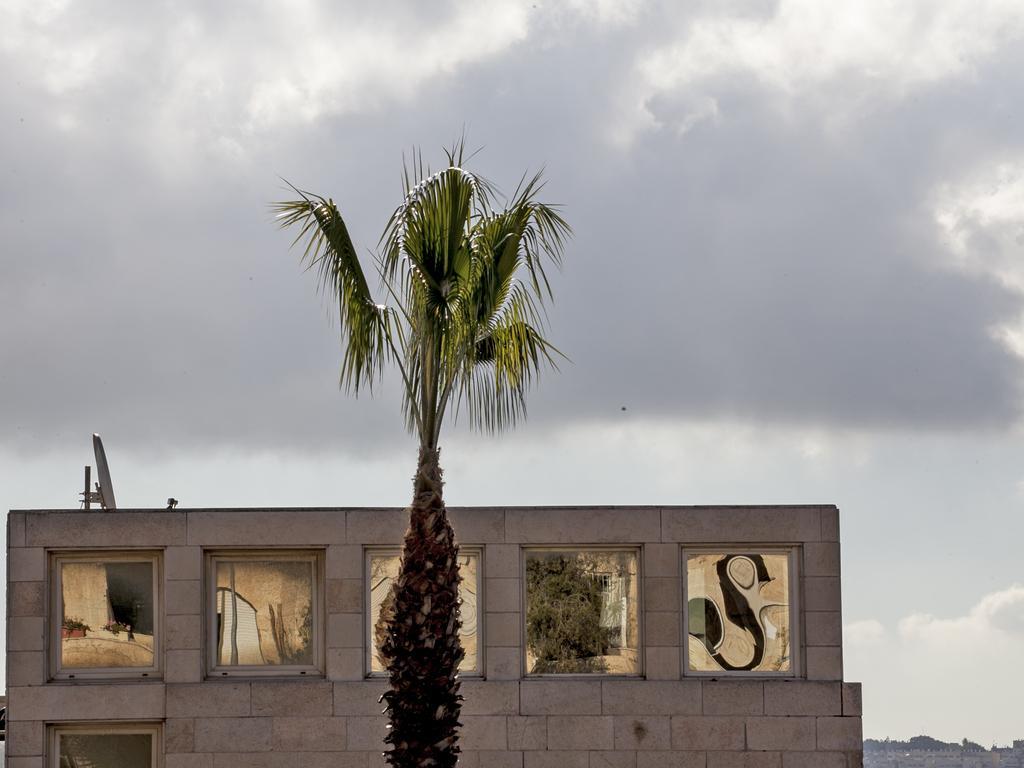Can you describe this image briefly? In this picture we can see a tree and a building, in the background we can find clouds. 